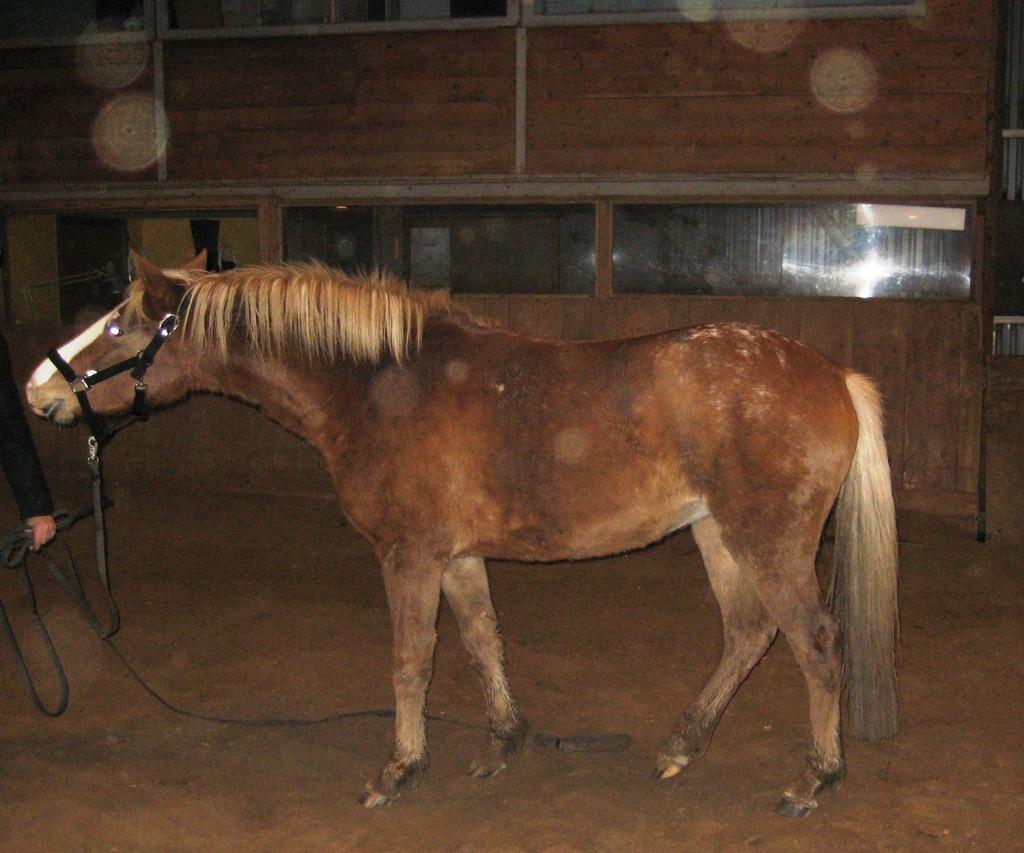How would you summarize this image in a sentence or two? In this image in the center there is an animal standing. On the left side there is a person holding a rope in hand. In the background there is a wooden wall and there is a glass. 